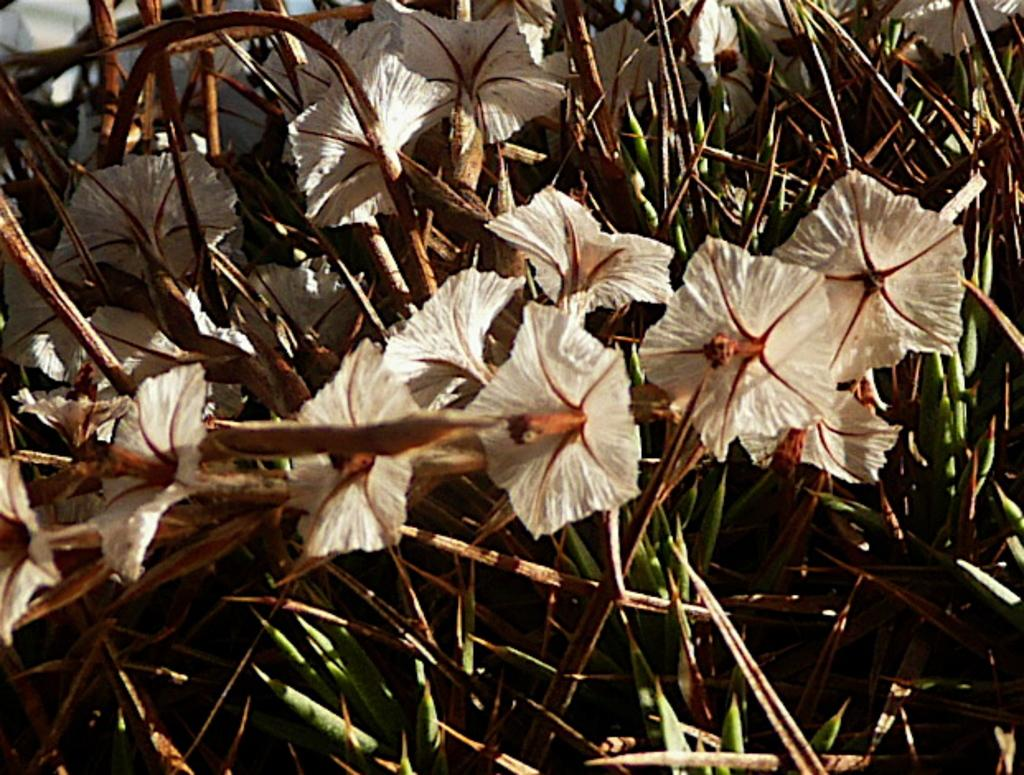What type of flower is on the plant in the image? There is a white flower on the plant in the image. What else can be seen at the bottom of the plant? There are leaves visible at the bottom of the plant. What can be seen in the background of the image? There is a white color car in the background of the image. How many nuts are on the marble furniture in the image? There are no nuts or marble furniture present in the image. 